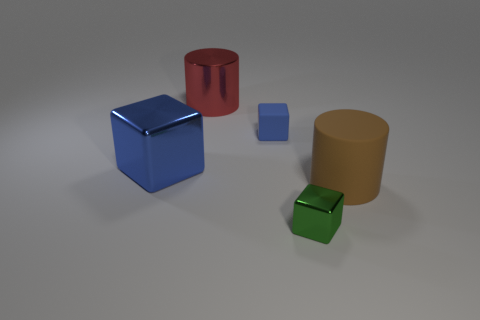There is another object that is the same color as the tiny rubber thing; what is its shape?
Your answer should be compact. Cube. What is the cube that is both on the right side of the red shiny object and behind the large brown rubber cylinder made of?
Offer a very short reply. Rubber. There is a tiny blue object; is its shape the same as the rubber object in front of the large block?
Give a very brief answer. No. What number of other things are there of the same size as the rubber cube?
Provide a succinct answer. 1. Are there more large rubber cylinders than yellow metal cylinders?
Provide a short and direct response. Yes. How many objects are both in front of the red shiny cylinder and behind the big brown matte cylinder?
Your answer should be very brief. 2. What is the shape of the tiny object that is behind the block that is in front of the big cylinder right of the small green thing?
Your answer should be very brief. Cube. How many balls are either big objects or large green metal things?
Provide a succinct answer. 0. Is the color of the big object right of the small metal block the same as the tiny rubber cube?
Provide a short and direct response. No. The thing that is to the left of the large metallic object behind the large shiny object that is in front of the red shiny thing is made of what material?
Provide a short and direct response. Metal. 